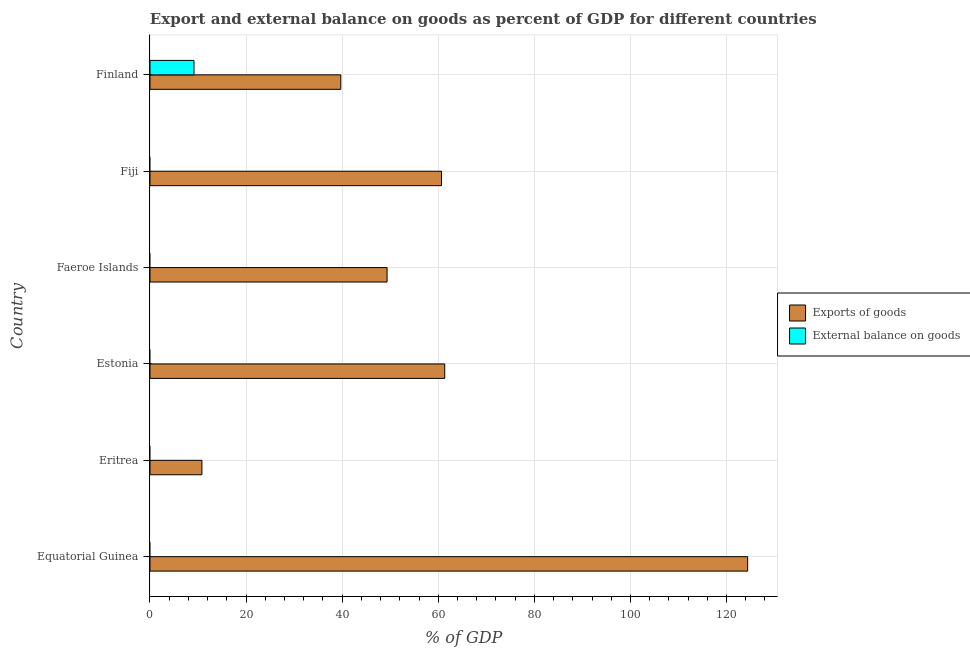How many different coloured bars are there?
Your response must be concise. 2. Are the number of bars on each tick of the Y-axis equal?
Keep it short and to the point. No. How many bars are there on the 5th tick from the top?
Your response must be concise. 1. What is the label of the 5th group of bars from the top?
Keep it short and to the point. Eritrea. What is the export of goods as percentage of gdp in Finland?
Your response must be concise. 39.71. Across all countries, what is the maximum export of goods as percentage of gdp?
Make the answer very short. 124.39. Across all countries, what is the minimum export of goods as percentage of gdp?
Offer a terse response. 10.81. In which country was the external balance on goods as percentage of gdp maximum?
Make the answer very short. Finland. What is the total external balance on goods as percentage of gdp in the graph?
Make the answer very short. 9.16. What is the difference between the export of goods as percentage of gdp in Eritrea and that in Estonia?
Your response must be concise. -50.54. What is the difference between the external balance on goods as percentage of gdp in Estonia and the export of goods as percentage of gdp in Equatorial Guinea?
Make the answer very short. -124.39. What is the average export of goods as percentage of gdp per country?
Your answer should be very brief. 57.71. What is the difference between the external balance on goods as percentage of gdp and export of goods as percentage of gdp in Finland?
Make the answer very short. -30.55. In how many countries, is the export of goods as percentage of gdp greater than 24 %?
Offer a very short reply. 5. What is the ratio of the export of goods as percentage of gdp in Eritrea to that in Faeroe Islands?
Offer a very short reply. 0.22. What is the difference between the highest and the second highest export of goods as percentage of gdp?
Give a very brief answer. 63.05. What is the difference between the highest and the lowest external balance on goods as percentage of gdp?
Your answer should be compact. 9.16. Are all the bars in the graph horizontal?
Keep it short and to the point. Yes. What is the difference between two consecutive major ticks on the X-axis?
Your answer should be compact. 20. How many legend labels are there?
Your response must be concise. 2. What is the title of the graph?
Ensure brevity in your answer.  Export and external balance on goods as percent of GDP for different countries. Does "Urban Population" appear as one of the legend labels in the graph?
Give a very brief answer. No. What is the label or title of the X-axis?
Provide a succinct answer. % of GDP. What is the label or title of the Y-axis?
Make the answer very short. Country. What is the % of GDP of Exports of goods in Equatorial Guinea?
Offer a very short reply. 124.39. What is the % of GDP in External balance on goods in Equatorial Guinea?
Ensure brevity in your answer.  0. What is the % of GDP of Exports of goods in Eritrea?
Offer a terse response. 10.81. What is the % of GDP of Exports of goods in Estonia?
Offer a very short reply. 61.35. What is the % of GDP in Exports of goods in Faeroe Islands?
Your answer should be very brief. 49.34. What is the % of GDP of External balance on goods in Faeroe Islands?
Provide a succinct answer. 0. What is the % of GDP of Exports of goods in Fiji?
Provide a short and direct response. 60.67. What is the % of GDP of Exports of goods in Finland?
Ensure brevity in your answer.  39.71. What is the % of GDP in External balance on goods in Finland?
Give a very brief answer. 9.16. Across all countries, what is the maximum % of GDP in Exports of goods?
Give a very brief answer. 124.39. Across all countries, what is the maximum % of GDP in External balance on goods?
Keep it short and to the point. 9.16. Across all countries, what is the minimum % of GDP of Exports of goods?
Offer a very short reply. 10.81. What is the total % of GDP in Exports of goods in the graph?
Provide a short and direct response. 346.28. What is the total % of GDP of External balance on goods in the graph?
Provide a short and direct response. 9.16. What is the difference between the % of GDP in Exports of goods in Equatorial Guinea and that in Eritrea?
Your response must be concise. 113.59. What is the difference between the % of GDP in Exports of goods in Equatorial Guinea and that in Estonia?
Your answer should be compact. 63.05. What is the difference between the % of GDP of Exports of goods in Equatorial Guinea and that in Faeroe Islands?
Your answer should be compact. 75.05. What is the difference between the % of GDP of Exports of goods in Equatorial Guinea and that in Fiji?
Make the answer very short. 63.72. What is the difference between the % of GDP in Exports of goods in Equatorial Guinea and that in Finland?
Offer a terse response. 84.68. What is the difference between the % of GDP in Exports of goods in Eritrea and that in Estonia?
Give a very brief answer. -50.54. What is the difference between the % of GDP in Exports of goods in Eritrea and that in Faeroe Islands?
Provide a short and direct response. -38.54. What is the difference between the % of GDP in Exports of goods in Eritrea and that in Fiji?
Offer a very short reply. -49.87. What is the difference between the % of GDP of Exports of goods in Eritrea and that in Finland?
Provide a succinct answer. -28.91. What is the difference between the % of GDP of Exports of goods in Estonia and that in Faeroe Islands?
Your answer should be very brief. 12. What is the difference between the % of GDP of Exports of goods in Estonia and that in Fiji?
Ensure brevity in your answer.  0.67. What is the difference between the % of GDP in Exports of goods in Estonia and that in Finland?
Your answer should be very brief. 21.63. What is the difference between the % of GDP of Exports of goods in Faeroe Islands and that in Fiji?
Your answer should be compact. -11.33. What is the difference between the % of GDP of Exports of goods in Faeroe Islands and that in Finland?
Make the answer very short. 9.63. What is the difference between the % of GDP in Exports of goods in Fiji and that in Finland?
Make the answer very short. 20.96. What is the difference between the % of GDP in Exports of goods in Equatorial Guinea and the % of GDP in External balance on goods in Finland?
Make the answer very short. 115.23. What is the difference between the % of GDP of Exports of goods in Eritrea and the % of GDP of External balance on goods in Finland?
Ensure brevity in your answer.  1.65. What is the difference between the % of GDP in Exports of goods in Estonia and the % of GDP in External balance on goods in Finland?
Keep it short and to the point. 52.19. What is the difference between the % of GDP in Exports of goods in Faeroe Islands and the % of GDP in External balance on goods in Finland?
Your response must be concise. 40.18. What is the difference between the % of GDP of Exports of goods in Fiji and the % of GDP of External balance on goods in Finland?
Your answer should be compact. 51.51. What is the average % of GDP of Exports of goods per country?
Ensure brevity in your answer.  57.71. What is the average % of GDP in External balance on goods per country?
Keep it short and to the point. 1.53. What is the difference between the % of GDP in Exports of goods and % of GDP in External balance on goods in Finland?
Your response must be concise. 30.55. What is the ratio of the % of GDP in Exports of goods in Equatorial Guinea to that in Eritrea?
Keep it short and to the point. 11.51. What is the ratio of the % of GDP of Exports of goods in Equatorial Guinea to that in Estonia?
Your answer should be very brief. 2.03. What is the ratio of the % of GDP of Exports of goods in Equatorial Guinea to that in Faeroe Islands?
Offer a very short reply. 2.52. What is the ratio of the % of GDP of Exports of goods in Equatorial Guinea to that in Fiji?
Your answer should be very brief. 2.05. What is the ratio of the % of GDP of Exports of goods in Equatorial Guinea to that in Finland?
Keep it short and to the point. 3.13. What is the ratio of the % of GDP of Exports of goods in Eritrea to that in Estonia?
Provide a succinct answer. 0.18. What is the ratio of the % of GDP in Exports of goods in Eritrea to that in Faeroe Islands?
Keep it short and to the point. 0.22. What is the ratio of the % of GDP in Exports of goods in Eritrea to that in Fiji?
Keep it short and to the point. 0.18. What is the ratio of the % of GDP in Exports of goods in Eritrea to that in Finland?
Your response must be concise. 0.27. What is the ratio of the % of GDP in Exports of goods in Estonia to that in Faeroe Islands?
Offer a very short reply. 1.24. What is the ratio of the % of GDP in Exports of goods in Estonia to that in Fiji?
Offer a very short reply. 1.01. What is the ratio of the % of GDP in Exports of goods in Estonia to that in Finland?
Offer a terse response. 1.54. What is the ratio of the % of GDP of Exports of goods in Faeroe Islands to that in Fiji?
Ensure brevity in your answer.  0.81. What is the ratio of the % of GDP of Exports of goods in Faeroe Islands to that in Finland?
Offer a very short reply. 1.24. What is the ratio of the % of GDP in Exports of goods in Fiji to that in Finland?
Ensure brevity in your answer.  1.53. What is the difference between the highest and the second highest % of GDP of Exports of goods?
Provide a short and direct response. 63.05. What is the difference between the highest and the lowest % of GDP of Exports of goods?
Provide a succinct answer. 113.59. What is the difference between the highest and the lowest % of GDP in External balance on goods?
Offer a terse response. 9.16. 